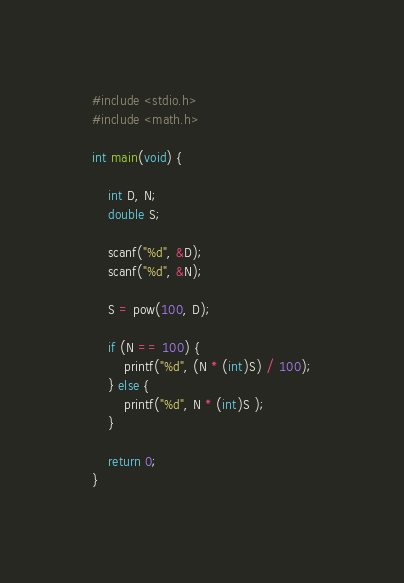<code> <loc_0><loc_0><loc_500><loc_500><_C_>#include <stdio.h>
#include <math.h>

int main(void) {

    int D, N;
    double S;

    scanf("%d", &D);
    scanf("%d", &N);

    S = pow(100, D);

    if (N == 100) {
        printf("%d", (N * (int)S) / 100);
    } else {
        printf("%d", N * (int)S );
    }

    return 0;
}</code> 